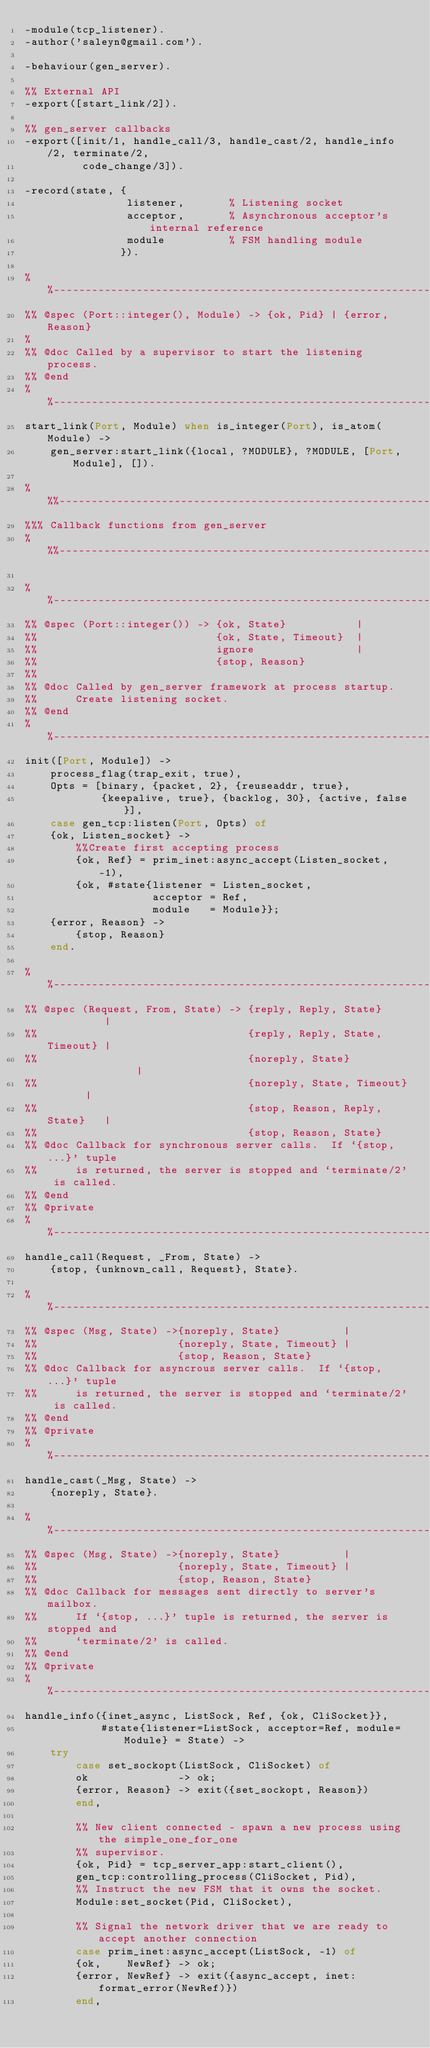<code> <loc_0><loc_0><loc_500><loc_500><_Erlang_>-module(tcp_listener).
-author('saleyn@gmail.com').
 
-behaviour(gen_server).
 
%% External API
-export([start_link/2]).
 
%% gen_server callbacks
-export([init/1, handle_call/3, handle_cast/2, handle_info/2, terminate/2,
         code_change/3]).
 
-record(state, {
                listener,       % Listening socket
                acceptor,       % Asynchronous acceptor's internal reference
                module          % FSM handling module
               }).
 
%%--------------------------------------------------------------------
%% @spec (Port::integer(), Module) -> {ok, Pid} | {error, Reason}
%
%% @doc Called by a supervisor to start the listening process.
%% @end
%%----------------------------------------------------------------------
start_link(Port, Module) when is_integer(Port), is_atom(Module) ->
    gen_server:start_link({local, ?MODULE}, ?MODULE, [Port, Module], []).
 
%%%------------------------------------------------------------------------
%%% Callback functions from gen_server
%%%------------------------------------------------------------------------
 
%%----------------------------------------------------------------------
%% @spec (Port::integer()) -> {ok, State}           |
%%                            {ok, State, Timeout}  |
%%                            ignore                |
%%                            {stop, Reason}
%%
%% @doc Called by gen_server framework at process startup.
%%      Create listening socket.
%% @end
%%----------------------------------------------------------------------
init([Port, Module]) ->
    process_flag(trap_exit, true),
    Opts = [binary, {packet, 2}, {reuseaddr, true},
            {keepalive, true}, {backlog, 30}, {active, false}],
    case gen_tcp:listen(Port, Opts) of
    {ok, Listen_socket} ->
        %%Create first accepting process
        {ok, Ref} = prim_inet:async_accept(Listen_socket, -1),
        {ok, #state{listener = Listen_socket,
                    acceptor = Ref,
                    module   = Module}};
    {error, Reason} ->
        {stop, Reason}
    end.
 
%%-------------------------------------------------------------------------
%% @spec (Request, From, State) -> {reply, Reply, State}          |
%%                                 {reply, Reply, State, Timeout} |
%%                                 {noreply, State}               |
%%                                 {noreply, State, Timeout}      |
%%                                 {stop, Reason, Reply, State}   |
%%                                 {stop, Reason, State}
%% @doc Callback for synchronous server calls.  If `{stop, ...}' tuple
%%      is returned, the server is stopped and `terminate/2' is called.
%% @end
%% @private
%%-------------------------------------------------------------------------
handle_call(Request, _From, State) ->
    {stop, {unknown_call, Request}, State}.
 
%%-------------------------------------------------------------------------
%% @spec (Msg, State) ->{noreply, State}          |
%%                      {noreply, State, Timeout} |
%%                      {stop, Reason, State}
%% @doc Callback for asyncrous server calls.  If `{stop, ...}' tuple
%%      is returned, the server is stopped and `terminate/2' is called.
%% @end
%% @private
%%-------------------------------------------------------------------------
handle_cast(_Msg, State) ->
    {noreply, State}.
 
%%-------------------------------------------------------------------------
%% @spec (Msg, State) ->{noreply, State}          |
%%                      {noreply, State, Timeout} |
%%                      {stop, Reason, State}
%% @doc Callback for messages sent directly to server's mailbox.
%%      If `{stop, ...}' tuple is returned, the server is stopped and
%%      `terminate/2' is called.
%% @end
%% @private
%%-------------------------------------------------------------------------
handle_info({inet_async, ListSock, Ref, {ok, CliSocket}},
            #state{listener=ListSock, acceptor=Ref, module=Module} = State) ->
    try
        case set_sockopt(ListSock, CliSocket) of
        ok              -> ok;
        {error, Reason} -> exit({set_sockopt, Reason})
        end,
 
        %% New client connected - spawn a new process using the simple_one_for_one
        %% supervisor.
        {ok, Pid} = tcp_server_app:start_client(),
        gen_tcp:controlling_process(CliSocket, Pid),
        %% Instruct the new FSM that it owns the socket.
        Module:set_socket(Pid, CliSocket),
 
        %% Signal the network driver that we are ready to accept another connection
        case prim_inet:async_accept(ListSock, -1) of
        {ok,    NewRef} -> ok;
        {error, NewRef} -> exit({async_accept, inet:format_error(NewRef)})
        end,
 </code> 